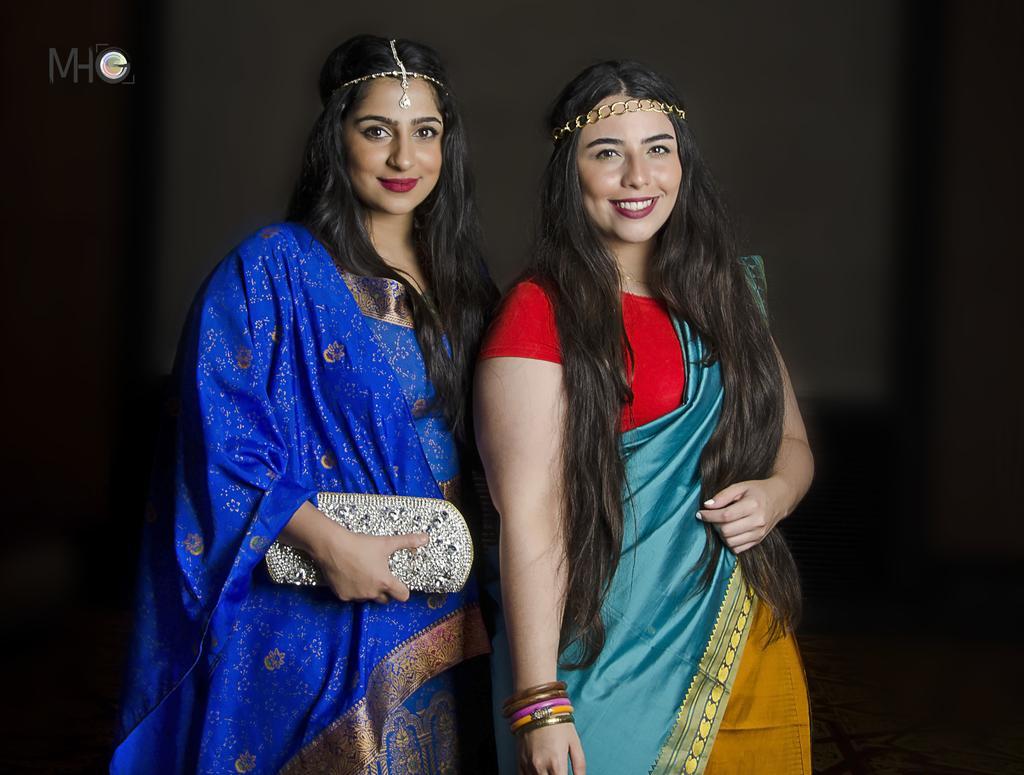Please provide a concise description of this image. In this image there are two persons, there is a person holding a purse, there is a text on the image, the background of the image is dark. 